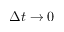Convert formula to latex. <formula><loc_0><loc_0><loc_500><loc_500>\Delta t \to 0</formula> 